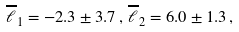<formula> <loc_0><loc_0><loc_500><loc_500>\overline { \ell } _ { 1 } = - 2 . 3 \pm 3 . 7 \, , \, \overline { \ell } _ { 2 } = 6 . 0 \pm 1 . 3 \, ,</formula> 